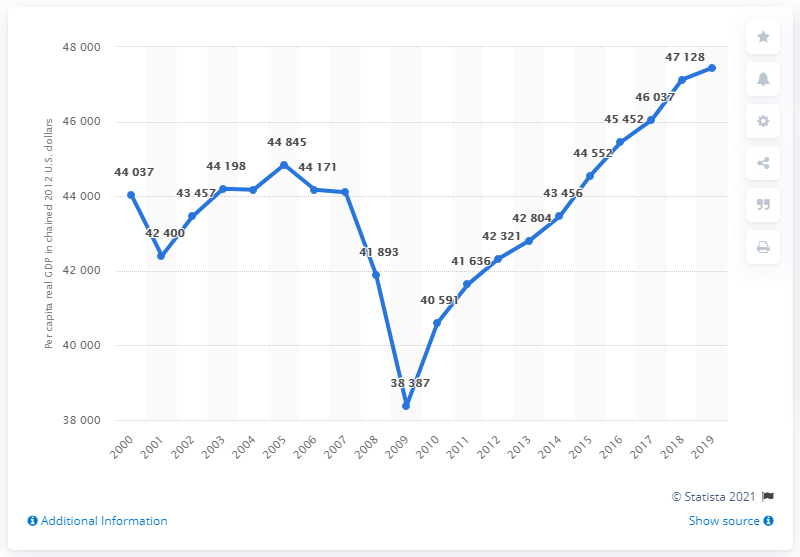Specify some key components in this picture. In 2012, the Gross Domestic Product (GDP) of the state of Michigan was chain-weighted. 